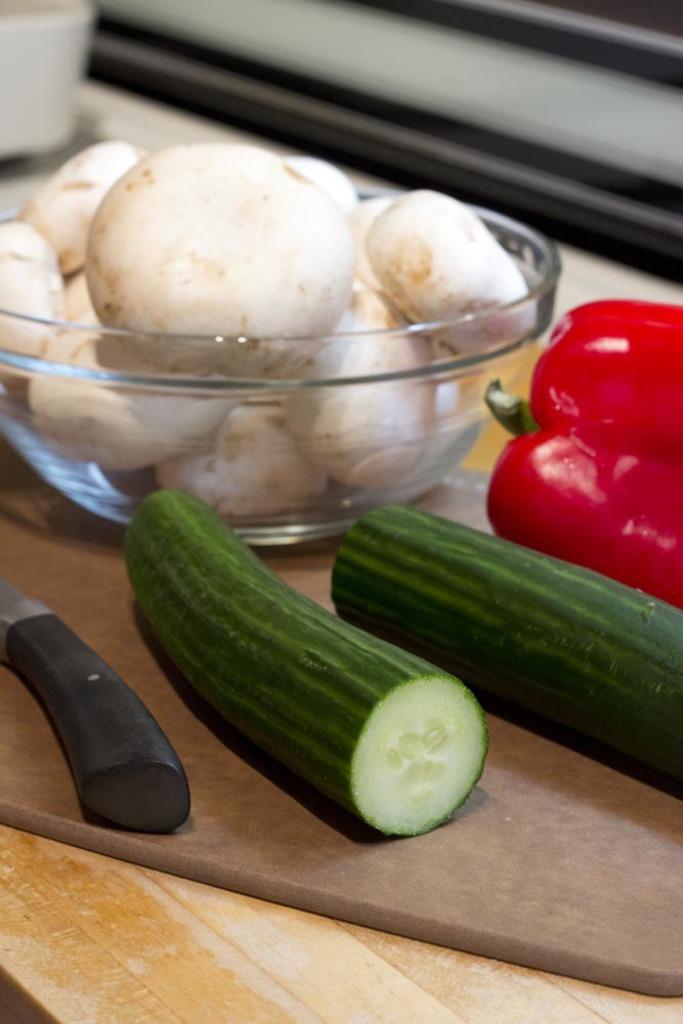How would you summarize this image in a sentence or two? In this picture I can observe vegetables placed in the bowl and some of them are placed on the table. They are in white, red and green colors. The background is blurred. 